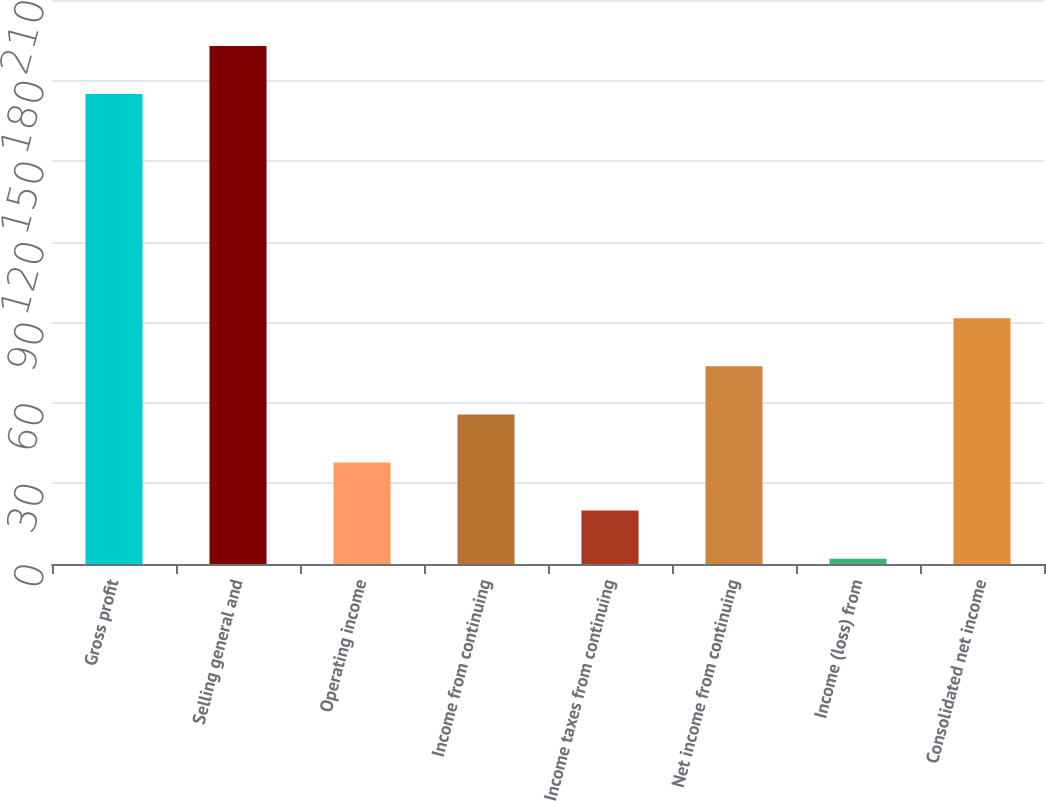Convert chart to OTSL. <chart><loc_0><loc_0><loc_500><loc_500><bar_chart><fcel>Gross profit<fcel>Selling general and<fcel>Operating income<fcel>Income from continuing<fcel>Income taxes from continuing<fcel>Net income from continuing<fcel>Income (loss) from<fcel>Consolidated net income<nl><fcel>175<fcel>192.9<fcel>37.8<fcel>55.7<fcel>19.9<fcel>73.6<fcel>2<fcel>91.5<nl></chart> 